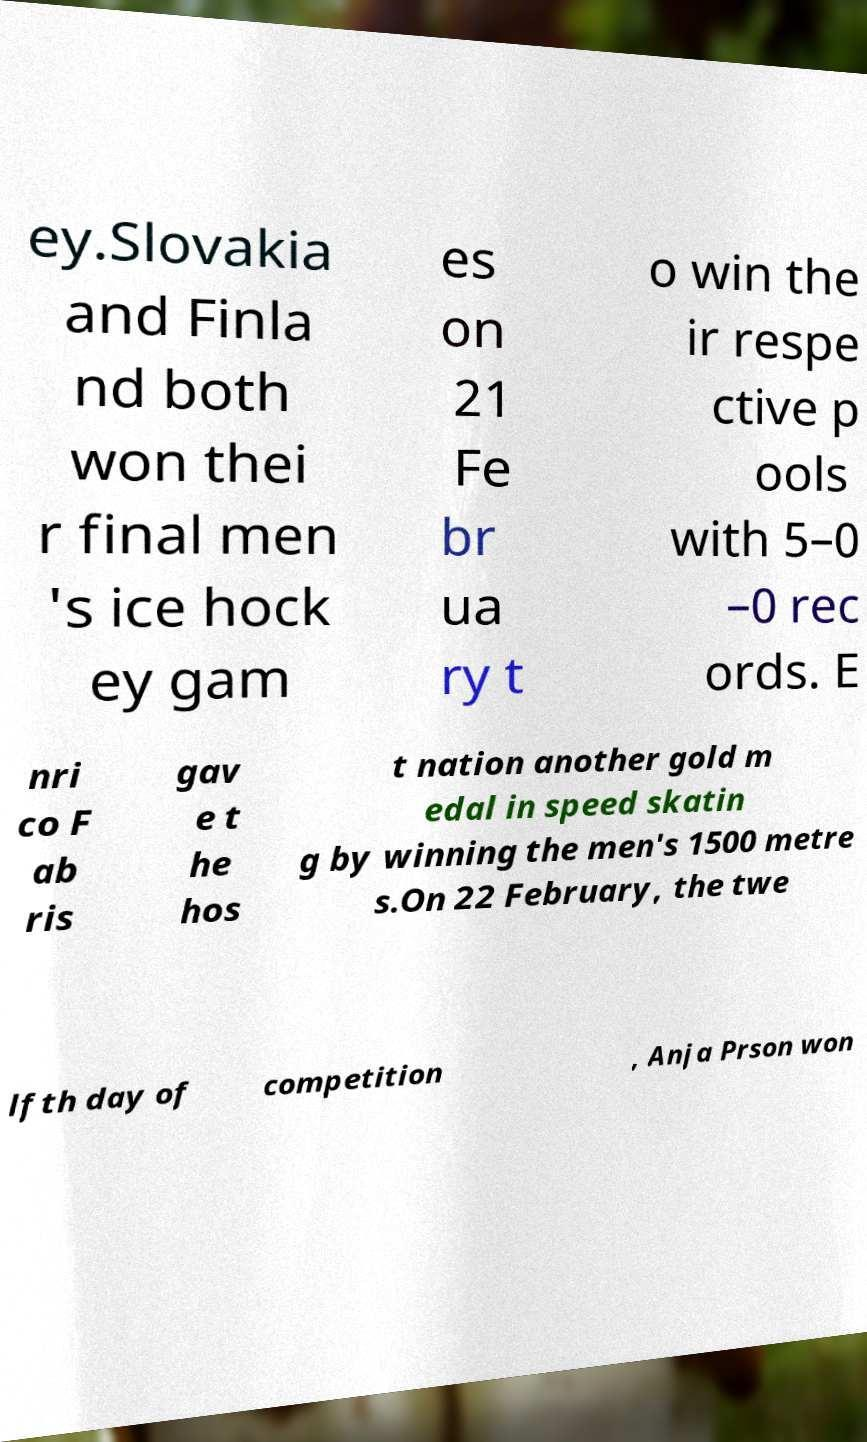For documentation purposes, I need the text within this image transcribed. Could you provide that? ey.Slovakia and Finla nd both won thei r final men 's ice hock ey gam es on 21 Fe br ua ry t o win the ir respe ctive p ools with 5–0 –0 rec ords. E nri co F ab ris gav e t he hos t nation another gold m edal in speed skatin g by winning the men's 1500 metre s.On 22 February, the twe lfth day of competition , Anja Prson won 